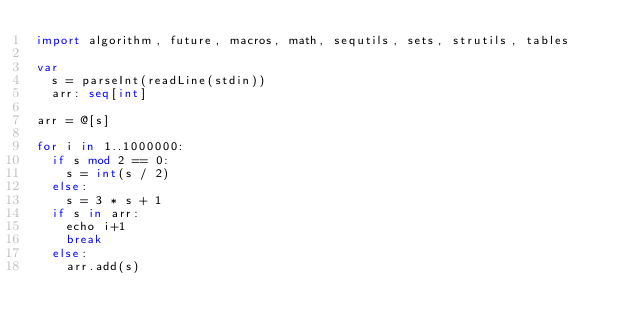Convert code to text. <code><loc_0><loc_0><loc_500><loc_500><_Nim_>import algorithm, future, macros, math, sequtils, sets, strutils, tables

var
  s = parseInt(readLine(stdin))
  arr: seq[int]

arr = @[s]

for i in 1..1000000:
  if s mod 2 == 0:
    s = int(s / 2)
  else:
    s = 3 * s + 1
  if s in arr:
    echo i+1
    break
  else:
    arr.add(s)</code> 